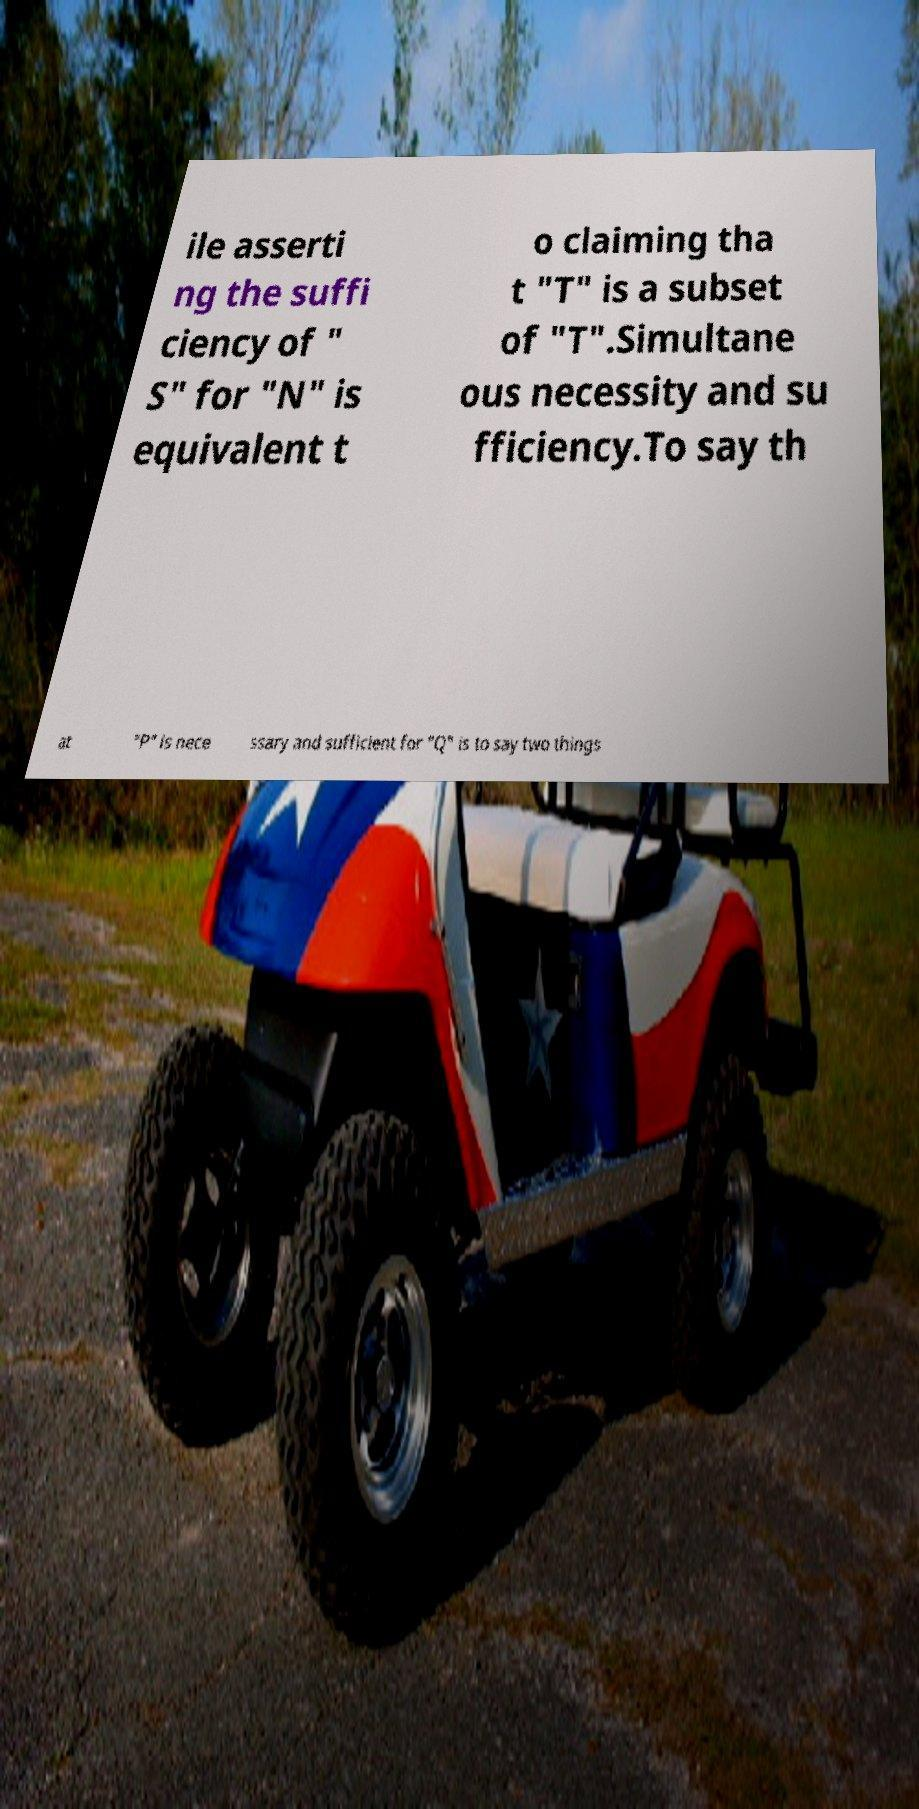What messages or text are displayed in this image? I need them in a readable, typed format. ile asserti ng the suffi ciency of " S" for "N" is equivalent t o claiming tha t "T" is a subset of "T".Simultane ous necessity and su fficiency.To say th at "P" is nece ssary and sufficient for "Q" is to say two things 